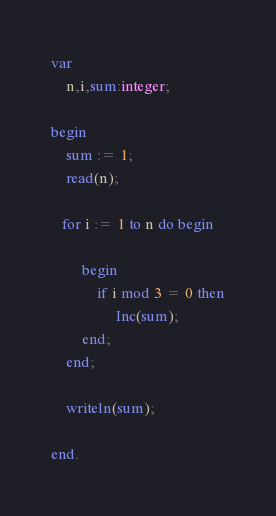Convert code to text. <code><loc_0><loc_0><loc_500><loc_500><_Pascal_>var
	n,i,sum:integer;
    
begin
	sum := 1;
	read(n);
    
   for i := 1 to n do begin
    	
        begin
        	if i mod 3 = 0 then
            	 Inc(sum);
        end;
    end;
    
    writeln(sum);

end.</code> 